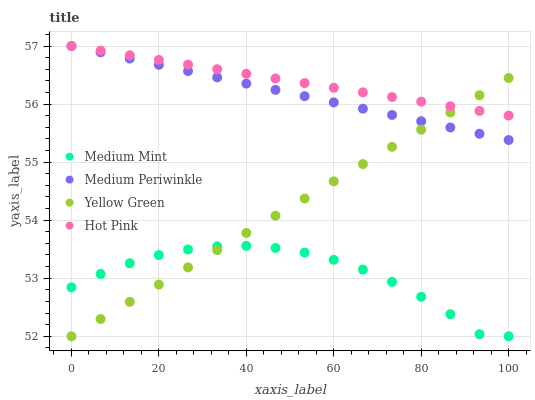Does Medium Mint have the minimum area under the curve?
Answer yes or no. Yes. Does Hot Pink have the maximum area under the curve?
Answer yes or no. Yes. Does Medium Periwinkle have the minimum area under the curve?
Answer yes or no. No. Does Medium Periwinkle have the maximum area under the curve?
Answer yes or no. No. Is Yellow Green the smoothest?
Answer yes or no. Yes. Is Medium Mint the roughest?
Answer yes or no. Yes. Is Hot Pink the smoothest?
Answer yes or no. No. Is Hot Pink the roughest?
Answer yes or no. No. Does Medium Mint have the lowest value?
Answer yes or no. Yes. Does Medium Periwinkle have the lowest value?
Answer yes or no. No. Does Medium Periwinkle have the highest value?
Answer yes or no. Yes. Does Yellow Green have the highest value?
Answer yes or no. No. Is Medium Mint less than Hot Pink?
Answer yes or no. Yes. Is Hot Pink greater than Medium Mint?
Answer yes or no. Yes. Does Hot Pink intersect Medium Periwinkle?
Answer yes or no. Yes. Is Hot Pink less than Medium Periwinkle?
Answer yes or no. No. Is Hot Pink greater than Medium Periwinkle?
Answer yes or no. No. Does Medium Mint intersect Hot Pink?
Answer yes or no. No. 